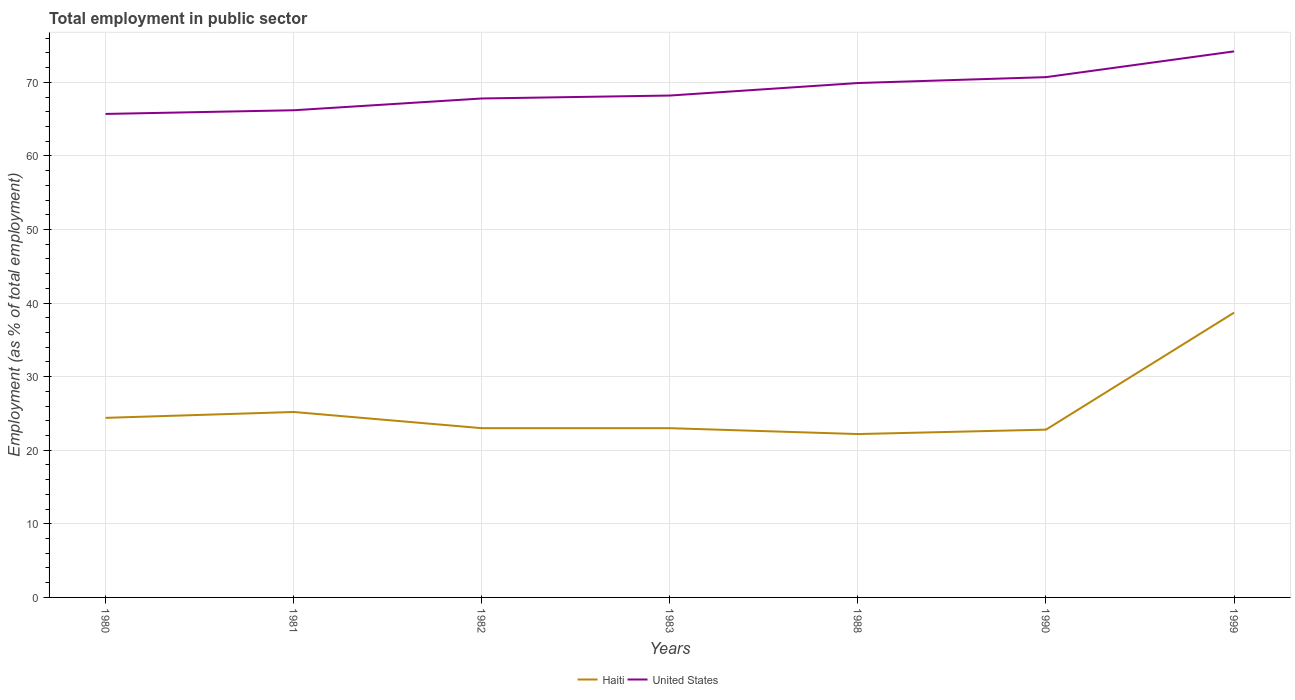Does the line corresponding to United States intersect with the line corresponding to Haiti?
Your answer should be compact. No. Across all years, what is the maximum employment in public sector in Haiti?
Provide a succinct answer. 22.2. In which year was the employment in public sector in Haiti maximum?
Give a very brief answer. 1988. What is the total employment in public sector in United States in the graph?
Keep it short and to the point. -6.4. Is the employment in public sector in United States strictly greater than the employment in public sector in Haiti over the years?
Your answer should be compact. No. Are the values on the major ticks of Y-axis written in scientific E-notation?
Offer a very short reply. No. What is the title of the graph?
Your response must be concise. Total employment in public sector. What is the label or title of the X-axis?
Your response must be concise. Years. What is the label or title of the Y-axis?
Provide a short and direct response. Employment (as % of total employment). What is the Employment (as % of total employment) of Haiti in 1980?
Make the answer very short. 24.4. What is the Employment (as % of total employment) of United States in 1980?
Your answer should be very brief. 65.7. What is the Employment (as % of total employment) in Haiti in 1981?
Offer a very short reply. 25.2. What is the Employment (as % of total employment) in United States in 1981?
Your answer should be very brief. 66.2. What is the Employment (as % of total employment) in Haiti in 1982?
Offer a very short reply. 23. What is the Employment (as % of total employment) in United States in 1982?
Provide a short and direct response. 67.8. What is the Employment (as % of total employment) of Haiti in 1983?
Offer a terse response. 23. What is the Employment (as % of total employment) in United States in 1983?
Make the answer very short. 68.2. What is the Employment (as % of total employment) in Haiti in 1988?
Keep it short and to the point. 22.2. What is the Employment (as % of total employment) in United States in 1988?
Your answer should be compact. 69.9. What is the Employment (as % of total employment) in Haiti in 1990?
Your response must be concise. 22.8. What is the Employment (as % of total employment) in United States in 1990?
Your answer should be compact. 70.7. What is the Employment (as % of total employment) in Haiti in 1999?
Make the answer very short. 38.7. What is the Employment (as % of total employment) of United States in 1999?
Ensure brevity in your answer.  74.2. Across all years, what is the maximum Employment (as % of total employment) of Haiti?
Your response must be concise. 38.7. Across all years, what is the maximum Employment (as % of total employment) in United States?
Your response must be concise. 74.2. Across all years, what is the minimum Employment (as % of total employment) in Haiti?
Give a very brief answer. 22.2. Across all years, what is the minimum Employment (as % of total employment) in United States?
Provide a succinct answer. 65.7. What is the total Employment (as % of total employment) of Haiti in the graph?
Keep it short and to the point. 179.3. What is the total Employment (as % of total employment) in United States in the graph?
Offer a very short reply. 482.7. What is the difference between the Employment (as % of total employment) in Haiti in 1980 and that in 1982?
Your answer should be very brief. 1.4. What is the difference between the Employment (as % of total employment) in United States in 1980 and that in 1982?
Your answer should be very brief. -2.1. What is the difference between the Employment (as % of total employment) in Haiti in 1980 and that in 1983?
Give a very brief answer. 1.4. What is the difference between the Employment (as % of total employment) in United States in 1980 and that in 1990?
Offer a very short reply. -5. What is the difference between the Employment (as % of total employment) of Haiti in 1980 and that in 1999?
Make the answer very short. -14.3. What is the difference between the Employment (as % of total employment) in United States in 1980 and that in 1999?
Your response must be concise. -8.5. What is the difference between the Employment (as % of total employment) in Haiti in 1981 and that in 1982?
Ensure brevity in your answer.  2.2. What is the difference between the Employment (as % of total employment) in Haiti in 1981 and that in 1983?
Offer a terse response. 2.2. What is the difference between the Employment (as % of total employment) in Haiti in 1981 and that in 1988?
Give a very brief answer. 3. What is the difference between the Employment (as % of total employment) of Haiti in 1981 and that in 1990?
Offer a very short reply. 2.4. What is the difference between the Employment (as % of total employment) of Haiti in 1981 and that in 1999?
Offer a very short reply. -13.5. What is the difference between the Employment (as % of total employment) of Haiti in 1982 and that in 1983?
Keep it short and to the point. 0. What is the difference between the Employment (as % of total employment) in United States in 1982 and that in 1990?
Your response must be concise. -2.9. What is the difference between the Employment (as % of total employment) of Haiti in 1982 and that in 1999?
Provide a short and direct response. -15.7. What is the difference between the Employment (as % of total employment) of United States in 1983 and that in 1988?
Your answer should be very brief. -1.7. What is the difference between the Employment (as % of total employment) in Haiti in 1983 and that in 1999?
Keep it short and to the point. -15.7. What is the difference between the Employment (as % of total employment) in United States in 1983 and that in 1999?
Make the answer very short. -6. What is the difference between the Employment (as % of total employment) in Haiti in 1988 and that in 1999?
Ensure brevity in your answer.  -16.5. What is the difference between the Employment (as % of total employment) of United States in 1988 and that in 1999?
Provide a short and direct response. -4.3. What is the difference between the Employment (as % of total employment) of Haiti in 1990 and that in 1999?
Ensure brevity in your answer.  -15.9. What is the difference between the Employment (as % of total employment) in United States in 1990 and that in 1999?
Your answer should be very brief. -3.5. What is the difference between the Employment (as % of total employment) in Haiti in 1980 and the Employment (as % of total employment) in United States in 1981?
Your answer should be compact. -41.8. What is the difference between the Employment (as % of total employment) of Haiti in 1980 and the Employment (as % of total employment) of United States in 1982?
Ensure brevity in your answer.  -43.4. What is the difference between the Employment (as % of total employment) of Haiti in 1980 and the Employment (as % of total employment) of United States in 1983?
Your answer should be very brief. -43.8. What is the difference between the Employment (as % of total employment) in Haiti in 1980 and the Employment (as % of total employment) in United States in 1988?
Offer a terse response. -45.5. What is the difference between the Employment (as % of total employment) in Haiti in 1980 and the Employment (as % of total employment) in United States in 1990?
Keep it short and to the point. -46.3. What is the difference between the Employment (as % of total employment) of Haiti in 1980 and the Employment (as % of total employment) of United States in 1999?
Make the answer very short. -49.8. What is the difference between the Employment (as % of total employment) in Haiti in 1981 and the Employment (as % of total employment) in United States in 1982?
Your answer should be compact. -42.6. What is the difference between the Employment (as % of total employment) of Haiti in 1981 and the Employment (as % of total employment) of United States in 1983?
Your answer should be very brief. -43. What is the difference between the Employment (as % of total employment) in Haiti in 1981 and the Employment (as % of total employment) in United States in 1988?
Your answer should be compact. -44.7. What is the difference between the Employment (as % of total employment) in Haiti in 1981 and the Employment (as % of total employment) in United States in 1990?
Your answer should be compact. -45.5. What is the difference between the Employment (as % of total employment) of Haiti in 1981 and the Employment (as % of total employment) of United States in 1999?
Offer a very short reply. -49. What is the difference between the Employment (as % of total employment) in Haiti in 1982 and the Employment (as % of total employment) in United States in 1983?
Your answer should be very brief. -45.2. What is the difference between the Employment (as % of total employment) of Haiti in 1982 and the Employment (as % of total employment) of United States in 1988?
Your answer should be very brief. -46.9. What is the difference between the Employment (as % of total employment) of Haiti in 1982 and the Employment (as % of total employment) of United States in 1990?
Your response must be concise. -47.7. What is the difference between the Employment (as % of total employment) in Haiti in 1982 and the Employment (as % of total employment) in United States in 1999?
Offer a very short reply. -51.2. What is the difference between the Employment (as % of total employment) of Haiti in 1983 and the Employment (as % of total employment) of United States in 1988?
Keep it short and to the point. -46.9. What is the difference between the Employment (as % of total employment) in Haiti in 1983 and the Employment (as % of total employment) in United States in 1990?
Your response must be concise. -47.7. What is the difference between the Employment (as % of total employment) of Haiti in 1983 and the Employment (as % of total employment) of United States in 1999?
Ensure brevity in your answer.  -51.2. What is the difference between the Employment (as % of total employment) of Haiti in 1988 and the Employment (as % of total employment) of United States in 1990?
Make the answer very short. -48.5. What is the difference between the Employment (as % of total employment) in Haiti in 1988 and the Employment (as % of total employment) in United States in 1999?
Provide a short and direct response. -52. What is the difference between the Employment (as % of total employment) in Haiti in 1990 and the Employment (as % of total employment) in United States in 1999?
Your answer should be compact. -51.4. What is the average Employment (as % of total employment) of Haiti per year?
Give a very brief answer. 25.61. What is the average Employment (as % of total employment) of United States per year?
Give a very brief answer. 68.96. In the year 1980, what is the difference between the Employment (as % of total employment) in Haiti and Employment (as % of total employment) in United States?
Your response must be concise. -41.3. In the year 1981, what is the difference between the Employment (as % of total employment) in Haiti and Employment (as % of total employment) in United States?
Offer a very short reply. -41. In the year 1982, what is the difference between the Employment (as % of total employment) in Haiti and Employment (as % of total employment) in United States?
Your answer should be very brief. -44.8. In the year 1983, what is the difference between the Employment (as % of total employment) in Haiti and Employment (as % of total employment) in United States?
Your response must be concise. -45.2. In the year 1988, what is the difference between the Employment (as % of total employment) in Haiti and Employment (as % of total employment) in United States?
Your response must be concise. -47.7. In the year 1990, what is the difference between the Employment (as % of total employment) in Haiti and Employment (as % of total employment) in United States?
Keep it short and to the point. -47.9. In the year 1999, what is the difference between the Employment (as % of total employment) of Haiti and Employment (as % of total employment) of United States?
Provide a succinct answer. -35.5. What is the ratio of the Employment (as % of total employment) in Haiti in 1980 to that in 1981?
Provide a succinct answer. 0.97. What is the ratio of the Employment (as % of total employment) of Haiti in 1980 to that in 1982?
Ensure brevity in your answer.  1.06. What is the ratio of the Employment (as % of total employment) in United States in 1980 to that in 1982?
Provide a succinct answer. 0.97. What is the ratio of the Employment (as % of total employment) of Haiti in 1980 to that in 1983?
Offer a terse response. 1.06. What is the ratio of the Employment (as % of total employment) in United States in 1980 to that in 1983?
Give a very brief answer. 0.96. What is the ratio of the Employment (as % of total employment) in Haiti in 1980 to that in 1988?
Offer a terse response. 1.1. What is the ratio of the Employment (as % of total employment) of United States in 1980 to that in 1988?
Your response must be concise. 0.94. What is the ratio of the Employment (as % of total employment) of Haiti in 1980 to that in 1990?
Keep it short and to the point. 1.07. What is the ratio of the Employment (as % of total employment) in United States in 1980 to that in 1990?
Your answer should be very brief. 0.93. What is the ratio of the Employment (as % of total employment) of Haiti in 1980 to that in 1999?
Keep it short and to the point. 0.63. What is the ratio of the Employment (as % of total employment) in United States in 1980 to that in 1999?
Your answer should be very brief. 0.89. What is the ratio of the Employment (as % of total employment) of Haiti in 1981 to that in 1982?
Your answer should be very brief. 1.1. What is the ratio of the Employment (as % of total employment) in United States in 1981 to that in 1982?
Your answer should be very brief. 0.98. What is the ratio of the Employment (as % of total employment) of Haiti in 1981 to that in 1983?
Offer a terse response. 1.1. What is the ratio of the Employment (as % of total employment) of United States in 1981 to that in 1983?
Keep it short and to the point. 0.97. What is the ratio of the Employment (as % of total employment) in Haiti in 1981 to that in 1988?
Your answer should be very brief. 1.14. What is the ratio of the Employment (as % of total employment) of United States in 1981 to that in 1988?
Provide a short and direct response. 0.95. What is the ratio of the Employment (as % of total employment) of Haiti in 1981 to that in 1990?
Your answer should be very brief. 1.11. What is the ratio of the Employment (as % of total employment) of United States in 1981 to that in 1990?
Give a very brief answer. 0.94. What is the ratio of the Employment (as % of total employment) of Haiti in 1981 to that in 1999?
Keep it short and to the point. 0.65. What is the ratio of the Employment (as % of total employment) in United States in 1981 to that in 1999?
Offer a very short reply. 0.89. What is the ratio of the Employment (as % of total employment) of Haiti in 1982 to that in 1988?
Ensure brevity in your answer.  1.04. What is the ratio of the Employment (as % of total employment) in Haiti in 1982 to that in 1990?
Your answer should be very brief. 1.01. What is the ratio of the Employment (as % of total employment) in Haiti in 1982 to that in 1999?
Your answer should be very brief. 0.59. What is the ratio of the Employment (as % of total employment) in United States in 1982 to that in 1999?
Provide a short and direct response. 0.91. What is the ratio of the Employment (as % of total employment) in Haiti in 1983 to that in 1988?
Provide a short and direct response. 1.04. What is the ratio of the Employment (as % of total employment) in United States in 1983 to that in 1988?
Your answer should be very brief. 0.98. What is the ratio of the Employment (as % of total employment) in Haiti in 1983 to that in 1990?
Provide a short and direct response. 1.01. What is the ratio of the Employment (as % of total employment) in United States in 1983 to that in 1990?
Provide a succinct answer. 0.96. What is the ratio of the Employment (as % of total employment) of Haiti in 1983 to that in 1999?
Ensure brevity in your answer.  0.59. What is the ratio of the Employment (as % of total employment) of United States in 1983 to that in 1999?
Ensure brevity in your answer.  0.92. What is the ratio of the Employment (as % of total employment) in Haiti in 1988 to that in 1990?
Give a very brief answer. 0.97. What is the ratio of the Employment (as % of total employment) of United States in 1988 to that in 1990?
Your answer should be compact. 0.99. What is the ratio of the Employment (as % of total employment) of Haiti in 1988 to that in 1999?
Give a very brief answer. 0.57. What is the ratio of the Employment (as % of total employment) of United States in 1988 to that in 1999?
Your answer should be very brief. 0.94. What is the ratio of the Employment (as % of total employment) in Haiti in 1990 to that in 1999?
Provide a short and direct response. 0.59. What is the ratio of the Employment (as % of total employment) in United States in 1990 to that in 1999?
Give a very brief answer. 0.95. What is the difference between the highest and the second highest Employment (as % of total employment) in Haiti?
Keep it short and to the point. 13.5. What is the difference between the highest and the lowest Employment (as % of total employment) of Haiti?
Your answer should be compact. 16.5. 